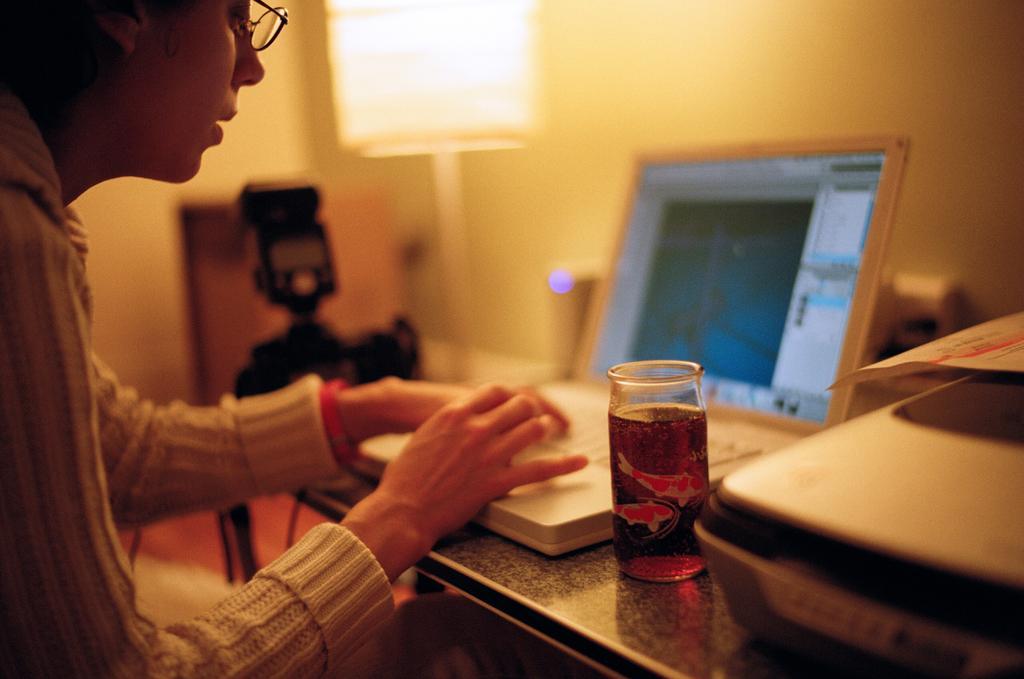In one or two sentences, can you explain what this image depicts? This picture shows a woman working on the laptop and we see a glass and a box and a paper on it on the table and we see a camera on the side and a stand light. 